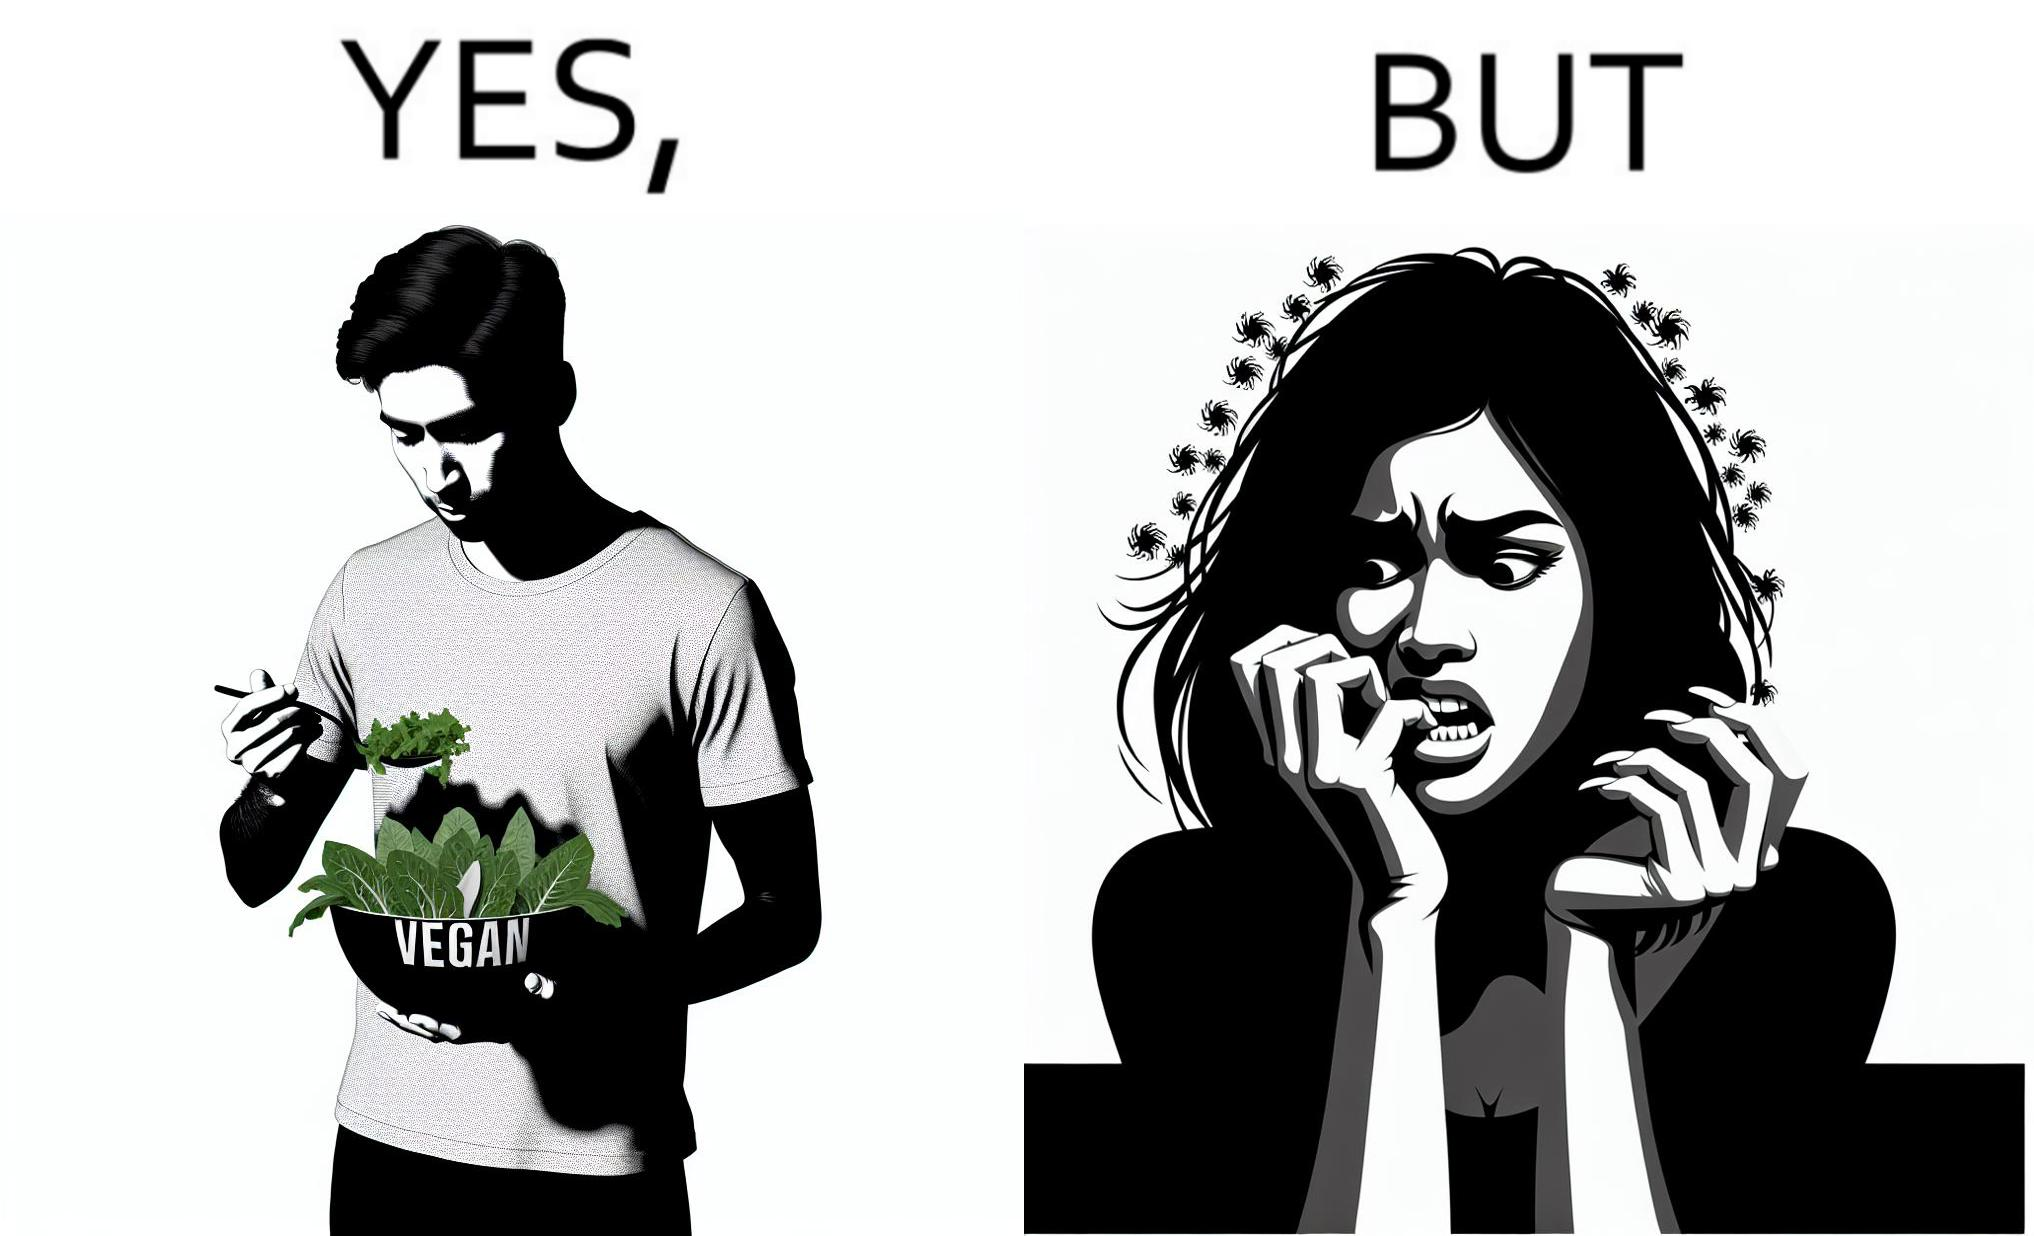Provide a description of this image. The image is funny because while the man claims to be vegan, he is biting skin off his own hand. 